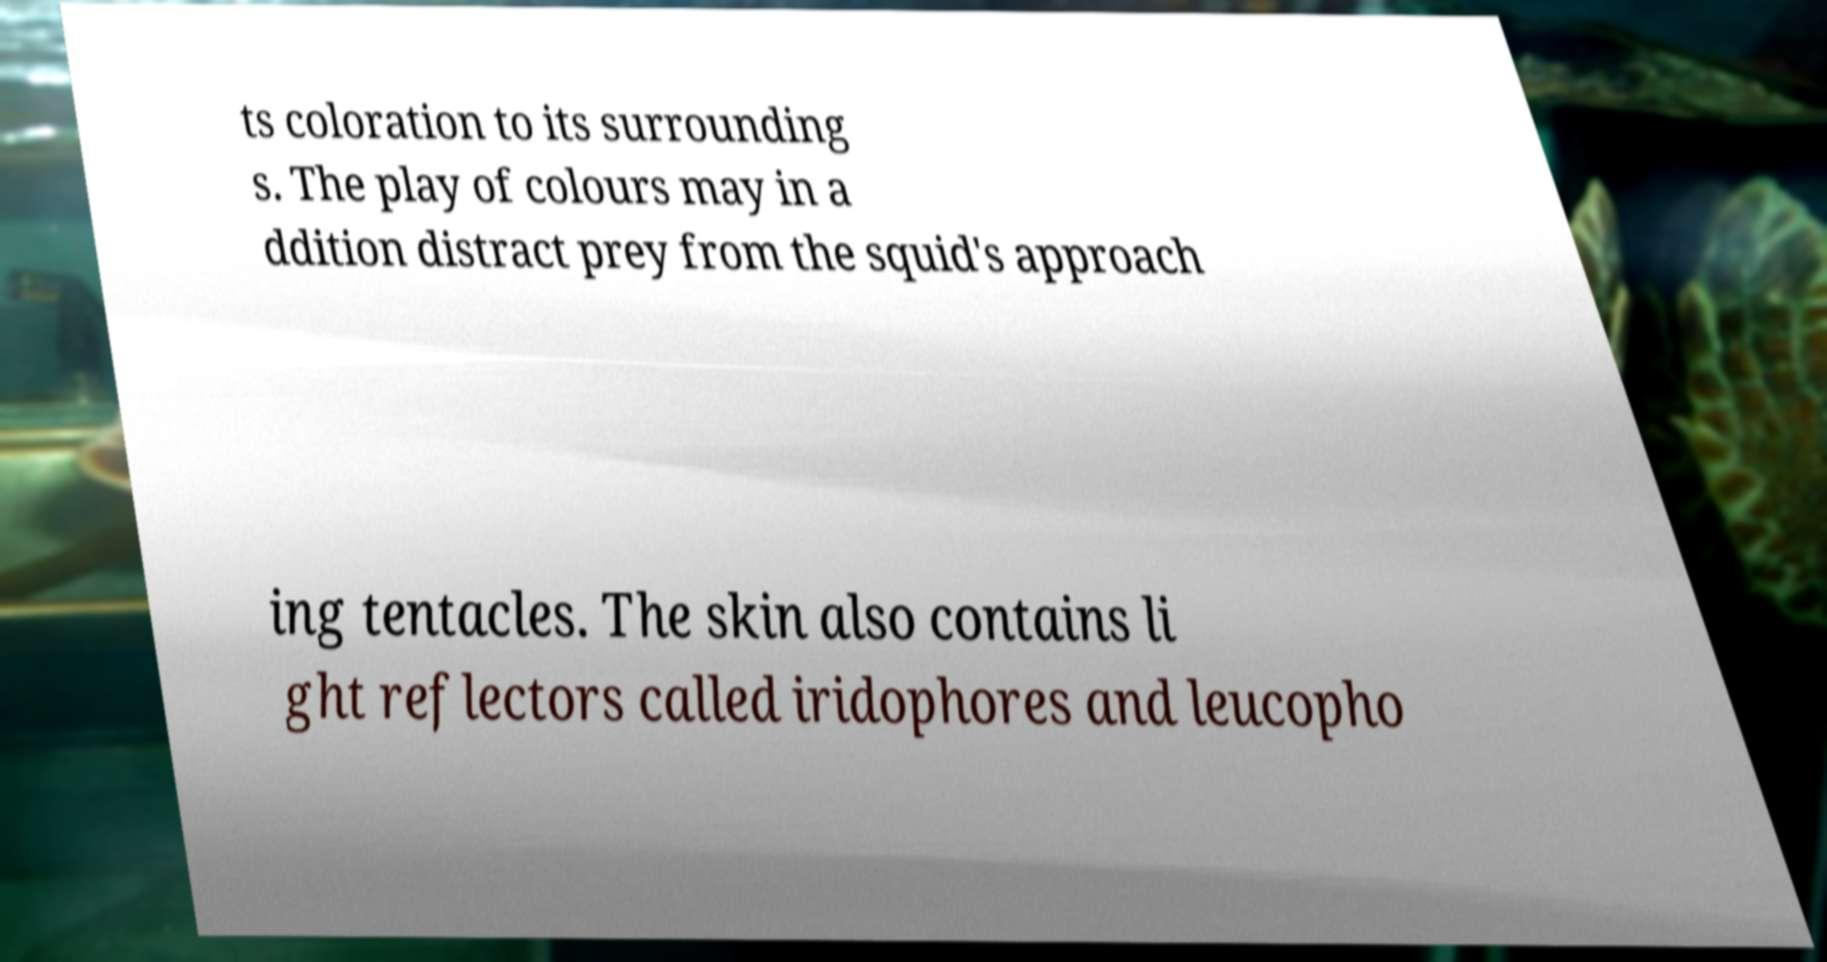Please identify and transcribe the text found in this image. ts coloration to its surrounding s. The play of colours may in a ddition distract prey from the squid's approach ing tentacles. The skin also contains li ght reflectors called iridophores and leucopho 